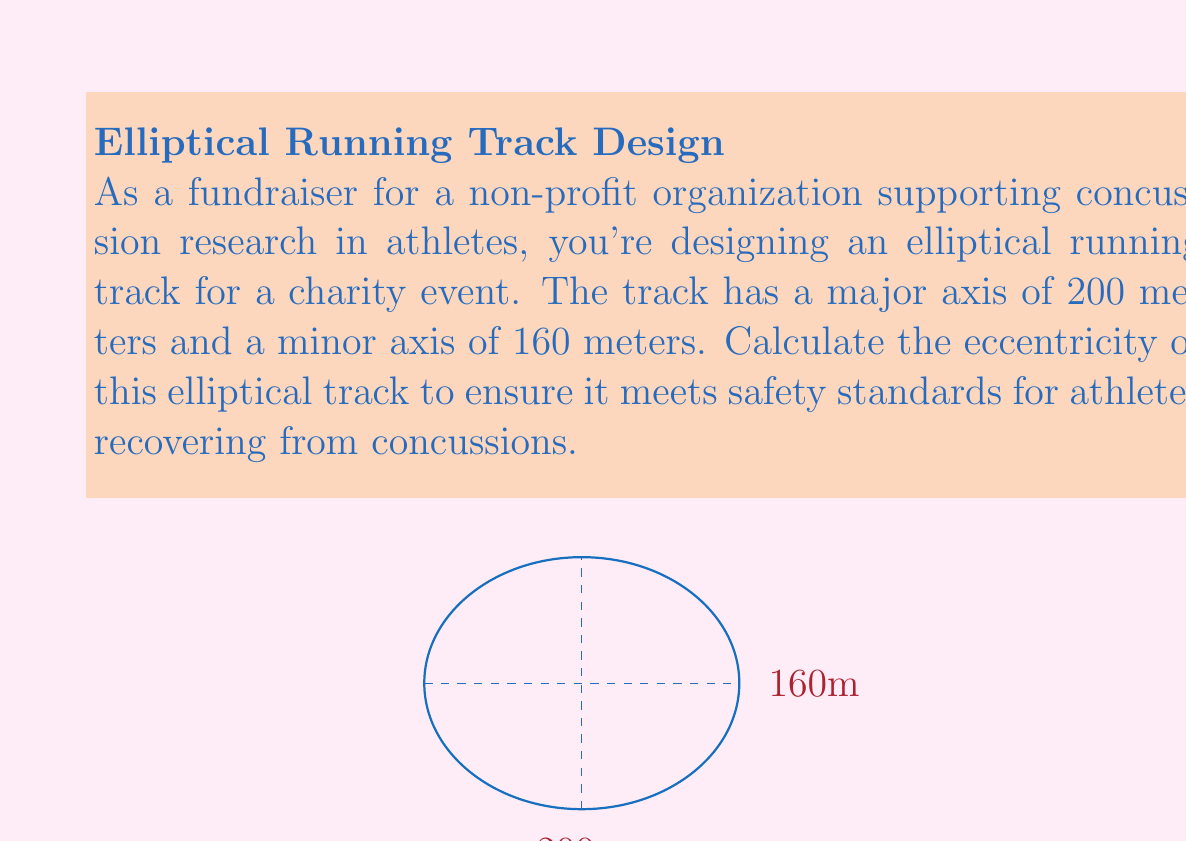Can you solve this math problem? Let's approach this step-by-step:

1) The eccentricity (e) of an ellipse is defined as:

   $$e = \sqrt{1 - \frac{b^2}{a^2}}$$

   where $a$ is the length of the semi-major axis and $b$ is the length of the semi-minor axis.

2) From the given information:
   - Major axis = 200 meters, so $a = 100$ meters
   - Minor axis = 160 meters, so $b = 80$ meters

3) Substitute these values into the eccentricity formula:

   $$e = \sqrt{1 - \frac{80^2}{100^2}}$$

4) Simplify inside the parentheses:

   $$e = \sqrt{1 - \frac{6400}{10000}}$$

5) Perform the division:

   $$e = \sqrt{1 - 0.64}$$

6) Subtract:

   $$e = \sqrt{0.36}$$

7) Take the square root:

   $$e = 0.6$$

Thus, the eccentricity of the elliptical running track is 0.6.
Answer: $e = 0.6$ 